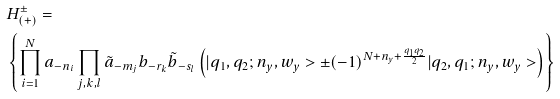<formula> <loc_0><loc_0><loc_500><loc_500>& H _ { ( + ) } ^ { \pm } = \\ & \left \{ \prod _ { i = 1 } ^ { N } a _ { - n _ { i } } \prod _ { j , k , l } \tilde { a } _ { - m _ { j } } b _ { - r _ { k } } \tilde { b } _ { - s _ { l } } \left ( | q _ { 1 } , q _ { 2 } ; n _ { y } , w _ { y } > \pm ( - 1 ) ^ { N + n _ { y } + \frac { q _ { 1 } q _ { 2 } } { 2 } } | q _ { 2 } , q _ { 1 } ; n _ { y } , w _ { y } > \right ) \right \}</formula> 